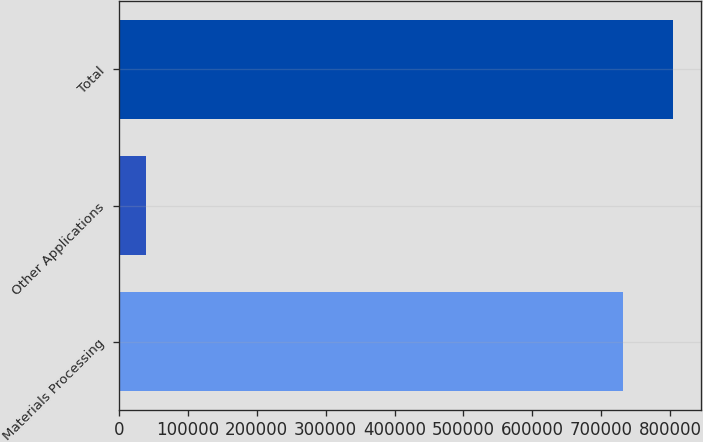Convert chart. <chart><loc_0><loc_0><loc_500><loc_500><bar_chart><fcel>Materials Processing<fcel>Other Applications<fcel>Total<nl><fcel>731274<fcel>38558<fcel>804401<nl></chart> 